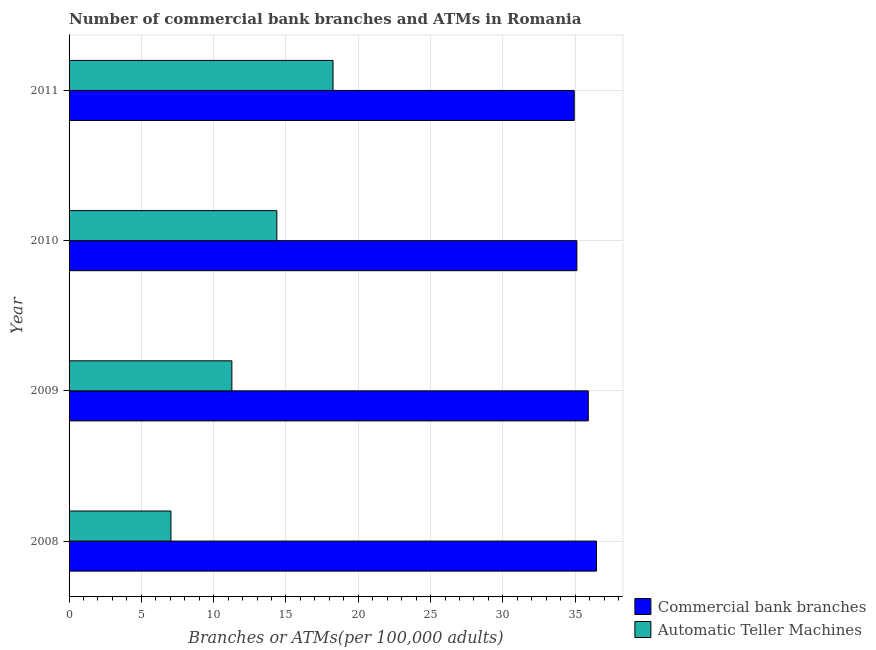Are the number of bars on each tick of the Y-axis equal?
Your answer should be very brief. Yes. How many bars are there on the 2nd tick from the top?
Provide a succinct answer. 2. How many bars are there on the 2nd tick from the bottom?
Your answer should be compact. 2. In how many cases, is the number of bars for a given year not equal to the number of legend labels?
Your answer should be very brief. 0. What is the number of commercal bank branches in 2009?
Your answer should be very brief. 35.91. Across all years, what is the maximum number of commercal bank branches?
Provide a succinct answer. 36.48. Across all years, what is the minimum number of commercal bank branches?
Provide a succinct answer. 34.94. In which year was the number of commercal bank branches maximum?
Your answer should be very brief. 2008. In which year was the number of atms minimum?
Offer a very short reply. 2008. What is the total number of atms in the graph?
Provide a short and direct response. 50.93. What is the difference between the number of commercal bank branches in 2010 and that in 2011?
Your response must be concise. 0.18. What is the difference between the number of commercal bank branches in 2008 and the number of atms in 2011?
Offer a terse response. 18.22. What is the average number of commercal bank branches per year?
Offer a very short reply. 35.61. In the year 2008, what is the difference between the number of atms and number of commercal bank branches?
Ensure brevity in your answer.  -29.43. What is the ratio of the number of commercal bank branches in 2008 to that in 2010?
Your answer should be compact. 1.04. Is the number of commercal bank branches in 2008 less than that in 2011?
Offer a very short reply. No. What is the difference between the highest and the second highest number of atms?
Your response must be concise. 3.89. What is the difference between the highest and the lowest number of commercal bank branches?
Your answer should be very brief. 1.54. Is the sum of the number of commercal bank branches in 2008 and 2010 greater than the maximum number of atms across all years?
Offer a terse response. Yes. What does the 1st bar from the top in 2009 represents?
Keep it short and to the point. Automatic Teller Machines. What does the 2nd bar from the bottom in 2008 represents?
Your answer should be very brief. Automatic Teller Machines. Are all the bars in the graph horizontal?
Provide a short and direct response. Yes. What is the difference between two consecutive major ticks on the X-axis?
Ensure brevity in your answer.  5. Does the graph contain any zero values?
Keep it short and to the point. No. Where does the legend appear in the graph?
Offer a terse response. Bottom right. How are the legend labels stacked?
Ensure brevity in your answer.  Vertical. What is the title of the graph?
Keep it short and to the point. Number of commercial bank branches and ATMs in Romania. Does "Official creditors" appear as one of the legend labels in the graph?
Give a very brief answer. No. What is the label or title of the X-axis?
Your answer should be very brief. Branches or ATMs(per 100,0 adults). What is the label or title of the Y-axis?
Ensure brevity in your answer.  Year. What is the Branches or ATMs(per 100,000 adults) of Commercial bank branches in 2008?
Offer a very short reply. 36.48. What is the Branches or ATMs(per 100,000 adults) of Automatic Teller Machines in 2008?
Offer a very short reply. 7.04. What is the Branches or ATMs(per 100,000 adults) in Commercial bank branches in 2009?
Ensure brevity in your answer.  35.91. What is the Branches or ATMs(per 100,000 adults) of Automatic Teller Machines in 2009?
Ensure brevity in your answer.  11.26. What is the Branches or ATMs(per 100,000 adults) in Commercial bank branches in 2010?
Ensure brevity in your answer.  35.12. What is the Branches or ATMs(per 100,000 adults) of Automatic Teller Machines in 2010?
Make the answer very short. 14.37. What is the Branches or ATMs(per 100,000 adults) of Commercial bank branches in 2011?
Provide a short and direct response. 34.94. What is the Branches or ATMs(per 100,000 adults) of Automatic Teller Machines in 2011?
Your response must be concise. 18.26. Across all years, what is the maximum Branches or ATMs(per 100,000 adults) of Commercial bank branches?
Give a very brief answer. 36.48. Across all years, what is the maximum Branches or ATMs(per 100,000 adults) in Automatic Teller Machines?
Ensure brevity in your answer.  18.26. Across all years, what is the minimum Branches or ATMs(per 100,000 adults) of Commercial bank branches?
Keep it short and to the point. 34.94. Across all years, what is the minimum Branches or ATMs(per 100,000 adults) in Automatic Teller Machines?
Offer a very short reply. 7.04. What is the total Branches or ATMs(per 100,000 adults) in Commercial bank branches in the graph?
Your answer should be very brief. 142.44. What is the total Branches or ATMs(per 100,000 adults) in Automatic Teller Machines in the graph?
Make the answer very short. 50.93. What is the difference between the Branches or ATMs(per 100,000 adults) of Commercial bank branches in 2008 and that in 2009?
Make the answer very short. 0.57. What is the difference between the Branches or ATMs(per 100,000 adults) in Automatic Teller Machines in 2008 and that in 2009?
Offer a terse response. -4.21. What is the difference between the Branches or ATMs(per 100,000 adults) of Commercial bank branches in 2008 and that in 2010?
Make the answer very short. 1.36. What is the difference between the Branches or ATMs(per 100,000 adults) in Automatic Teller Machines in 2008 and that in 2010?
Give a very brief answer. -7.32. What is the difference between the Branches or ATMs(per 100,000 adults) of Commercial bank branches in 2008 and that in 2011?
Offer a very short reply. 1.54. What is the difference between the Branches or ATMs(per 100,000 adults) of Automatic Teller Machines in 2008 and that in 2011?
Offer a very short reply. -11.21. What is the difference between the Branches or ATMs(per 100,000 adults) in Commercial bank branches in 2009 and that in 2010?
Keep it short and to the point. 0.79. What is the difference between the Branches or ATMs(per 100,000 adults) of Automatic Teller Machines in 2009 and that in 2010?
Provide a short and direct response. -3.11. What is the difference between the Branches or ATMs(per 100,000 adults) in Commercial bank branches in 2009 and that in 2011?
Ensure brevity in your answer.  0.97. What is the difference between the Branches or ATMs(per 100,000 adults) of Automatic Teller Machines in 2009 and that in 2011?
Make the answer very short. -7. What is the difference between the Branches or ATMs(per 100,000 adults) in Commercial bank branches in 2010 and that in 2011?
Your answer should be compact. 0.18. What is the difference between the Branches or ATMs(per 100,000 adults) of Automatic Teller Machines in 2010 and that in 2011?
Offer a very short reply. -3.89. What is the difference between the Branches or ATMs(per 100,000 adults) in Commercial bank branches in 2008 and the Branches or ATMs(per 100,000 adults) in Automatic Teller Machines in 2009?
Offer a very short reply. 25.22. What is the difference between the Branches or ATMs(per 100,000 adults) of Commercial bank branches in 2008 and the Branches or ATMs(per 100,000 adults) of Automatic Teller Machines in 2010?
Offer a terse response. 22.11. What is the difference between the Branches or ATMs(per 100,000 adults) of Commercial bank branches in 2008 and the Branches or ATMs(per 100,000 adults) of Automatic Teller Machines in 2011?
Ensure brevity in your answer.  18.22. What is the difference between the Branches or ATMs(per 100,000 adults) of Commercial bank branches in 2009 and the Branches or ATMs(per 100,000 adults) of Automatic Teller Machines in 2010?
Provide a short and direct response. 21.54. What is the difference between the Branches or ATMs(per 100,000 adults) of Commercial bank branches in 2009 and the Branches or ATMs(per 100,000 adults) of Automatic Teller Machines in 2011?
Keep it short and to the point. 17.65. What is the difference between the Branches or ATMs(per 100,000 adults) in Commercial bank branches in 2010 and the Branches or ATMs(per 100,000 adults) in Automatic Teller Machines in 2011?
Your answer should be very brief. 16.86. What is the average Branches or ATMs(per 100,000 adults) of Commercial bank branches per year?
Your response must be concise. 35.61. What is the average Branches or ATMs(per 100,000 adults) in Automatic Teller Machines per year?
Keep it short and to the point. 12.73. In the year 2008, what is the difference between the Branches or ATMs(per 100,000 adults) in Commercial bank branches and Branches or ATMs(per 100,000 adults) in Automatic Teller Machines?
Your answer should be compact. 29.43. In the year 2009, what is the difference between the Branches or ATMs(per 100,000 adults) in Commercial bank branches and Branches or ATMs(per 100,000 adults) in Automatic Teller Machines?
Ensure brevity in your answer.  24.65. In the year 2010, what is the difference between the Branches or ATMs(per 100,000 adults) in Commercial bank branches and Branches or ATMs(per 100,000 adults) in Automatic Teller Machines?
Offer a very short reply. 20.75. In the year 2011, what is the difference between the Branches or ATMs(per 100,000 adults) in Commercial bank branches and Branches or ATMs(per 100,000 adults) in Automatic Teller Machines?
Make the answer very short. 16.68. What is the ratio of the Branches or ATMs(per 100,000 adults) of Commercial bank branches in 2008 to that in 2009?
Provide a succinct answer. 1.02. What is the ratio of the Branches or ATMs(per 100,000 adults) of Automatic Teller Machines in 2008 to that in 2009?
Your answer should be very brief. 0.63. What is the ratio of the Branches or ATMs(per 100,000 adults) in Commercial bank branches in 2008 to that in 2010?
Provide a short and direct response. 1.04. What is the ratio of the Branches or ATMs(per 100,000 adults) of Automatic Teller Machines in 2008 to that in 2010?
Offer a very short reply. 0.49. What is the ratio of the Branches or ATMs(per 100,000 adults) of Commercial bank branches in 2008 to that in 2011?
Give a very brief answer. 1.04. What is the ratio of the Branches or ATMs(per 100,000 adults) in Automatic Teller Machines in 2008 to that in 2011?
Make the answer very short. 0.39. What is the ratio of the Branches or ATMs(per 100,000 adults) in Commercial bank branches in 2009 to that in 2010?
Make the answer very short. 1.02. What is the ratio of the Branches or ATMs(per 100,000 adults) in Automatic Teller Machines in 2009 to that in 2010?
Keep it short and to the point. 0.78. What is the ratio of the Branches or ATMs(per 100,000 adults) in Commercial bank branches in 2009 to that in 2011?
Keep it short and to the point. 1.03. What is the ratio of the Branches or ATMs(per 100,000 adults) in Automatic Teller Machines in 2009 to that in 2011?
Offer a very short reply. 0.62. What is the ratio of the Branches or ATMs(per 100,000 adults) of Commercial bank branches in 2010 to that in 2011?
Make the answer very short. 1.01. What is the ratio of the Branches or ATMs(per 100,000 adults) in Automatic Teller Machines in 2010 to that in 2011?
Ensure brevity in your answer.  0.79. What is the difference between the highest and the second highest Branches or ATMs(per 100,000 adults) in Commercial bank branches?
Offer a terse response. 0.57. What is the difference between the highest and the second highest Branches or ATMs(per 100,000 adults) of Automatic Teller Machines?
Make the answer very short. 3.89. What is the difference between the highest and the lowest Branches or ATMs(per 100,000 adults) of Commercial bank branches?
Offer a terse response. 1.54. What is the difference between the highest and the lowest Branches or ATMs(per 100,000 adults) in Automatic Teller Machines?
Ensure brevity in your answer.  11.21. 